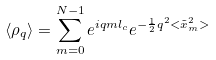Convert formula to latex. <formula><loc_0><loc_0><loc_500><loc_500>\left < \rho _ { q } \right > = \sum _ { m = 0 } ^ { N - 1 } e ^ { i q m l _ { c } } e ^ { - \frac { 1 } { 2 } q ^ { 2 } < { \tilde { x } } ^ { 2 } _ { m } > }</formula> 